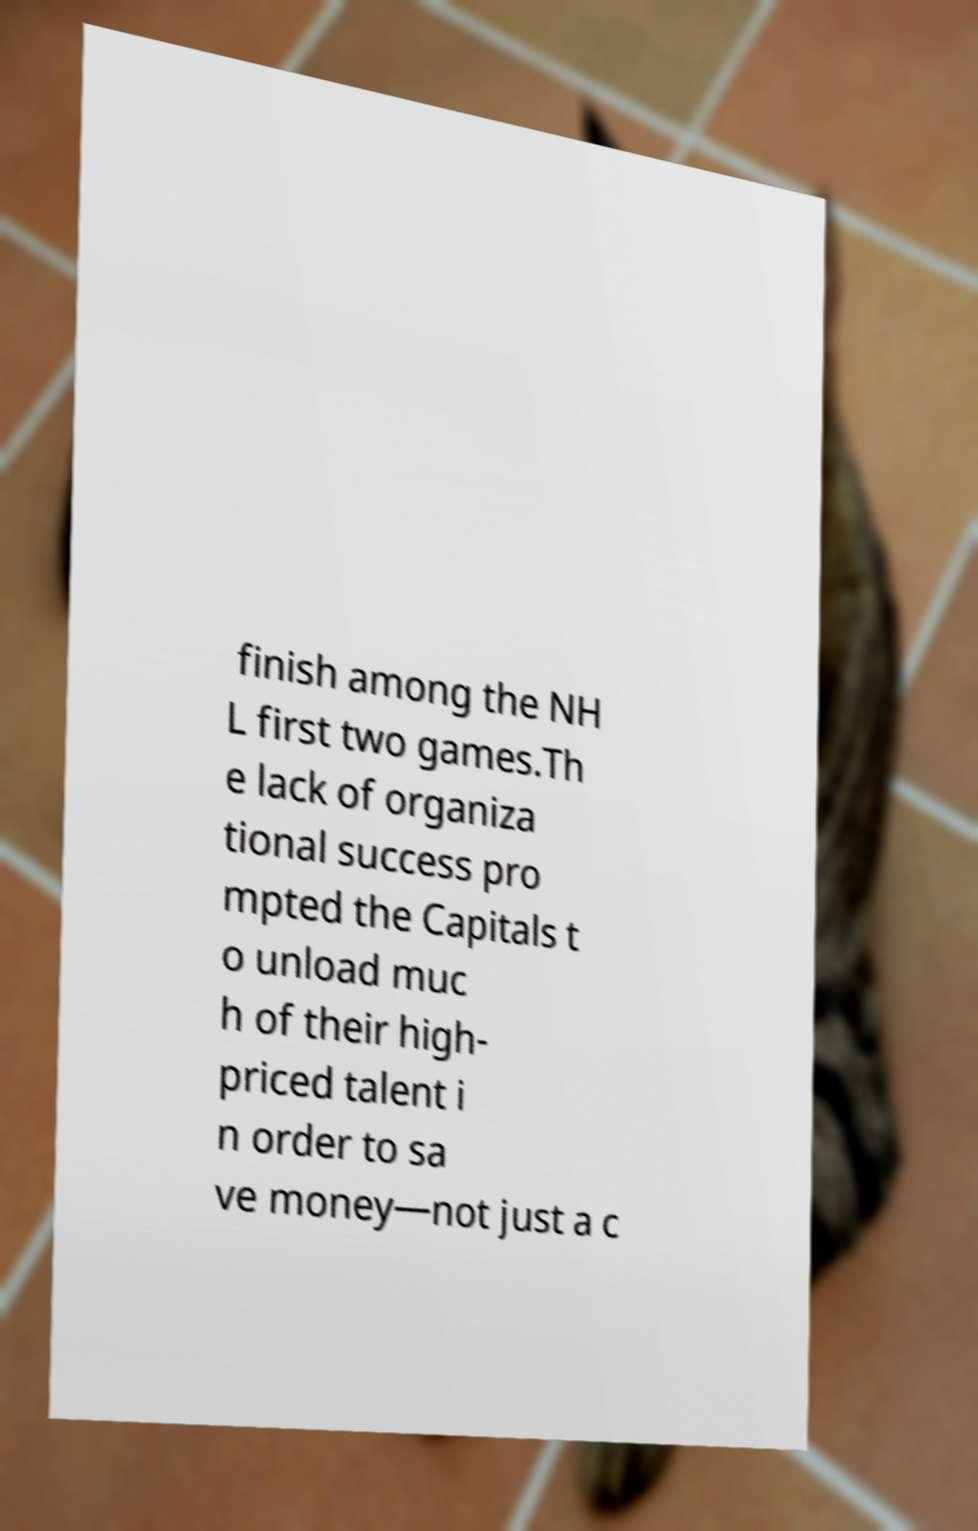Could you assist in decoding the text presented in this image and type it out clearly? finish among the NH L first two games.Th e lack of organiza tional success pro mpted the Capitals t o unload muc h of their high- priced talent i n order to sa ve money—not just a c 